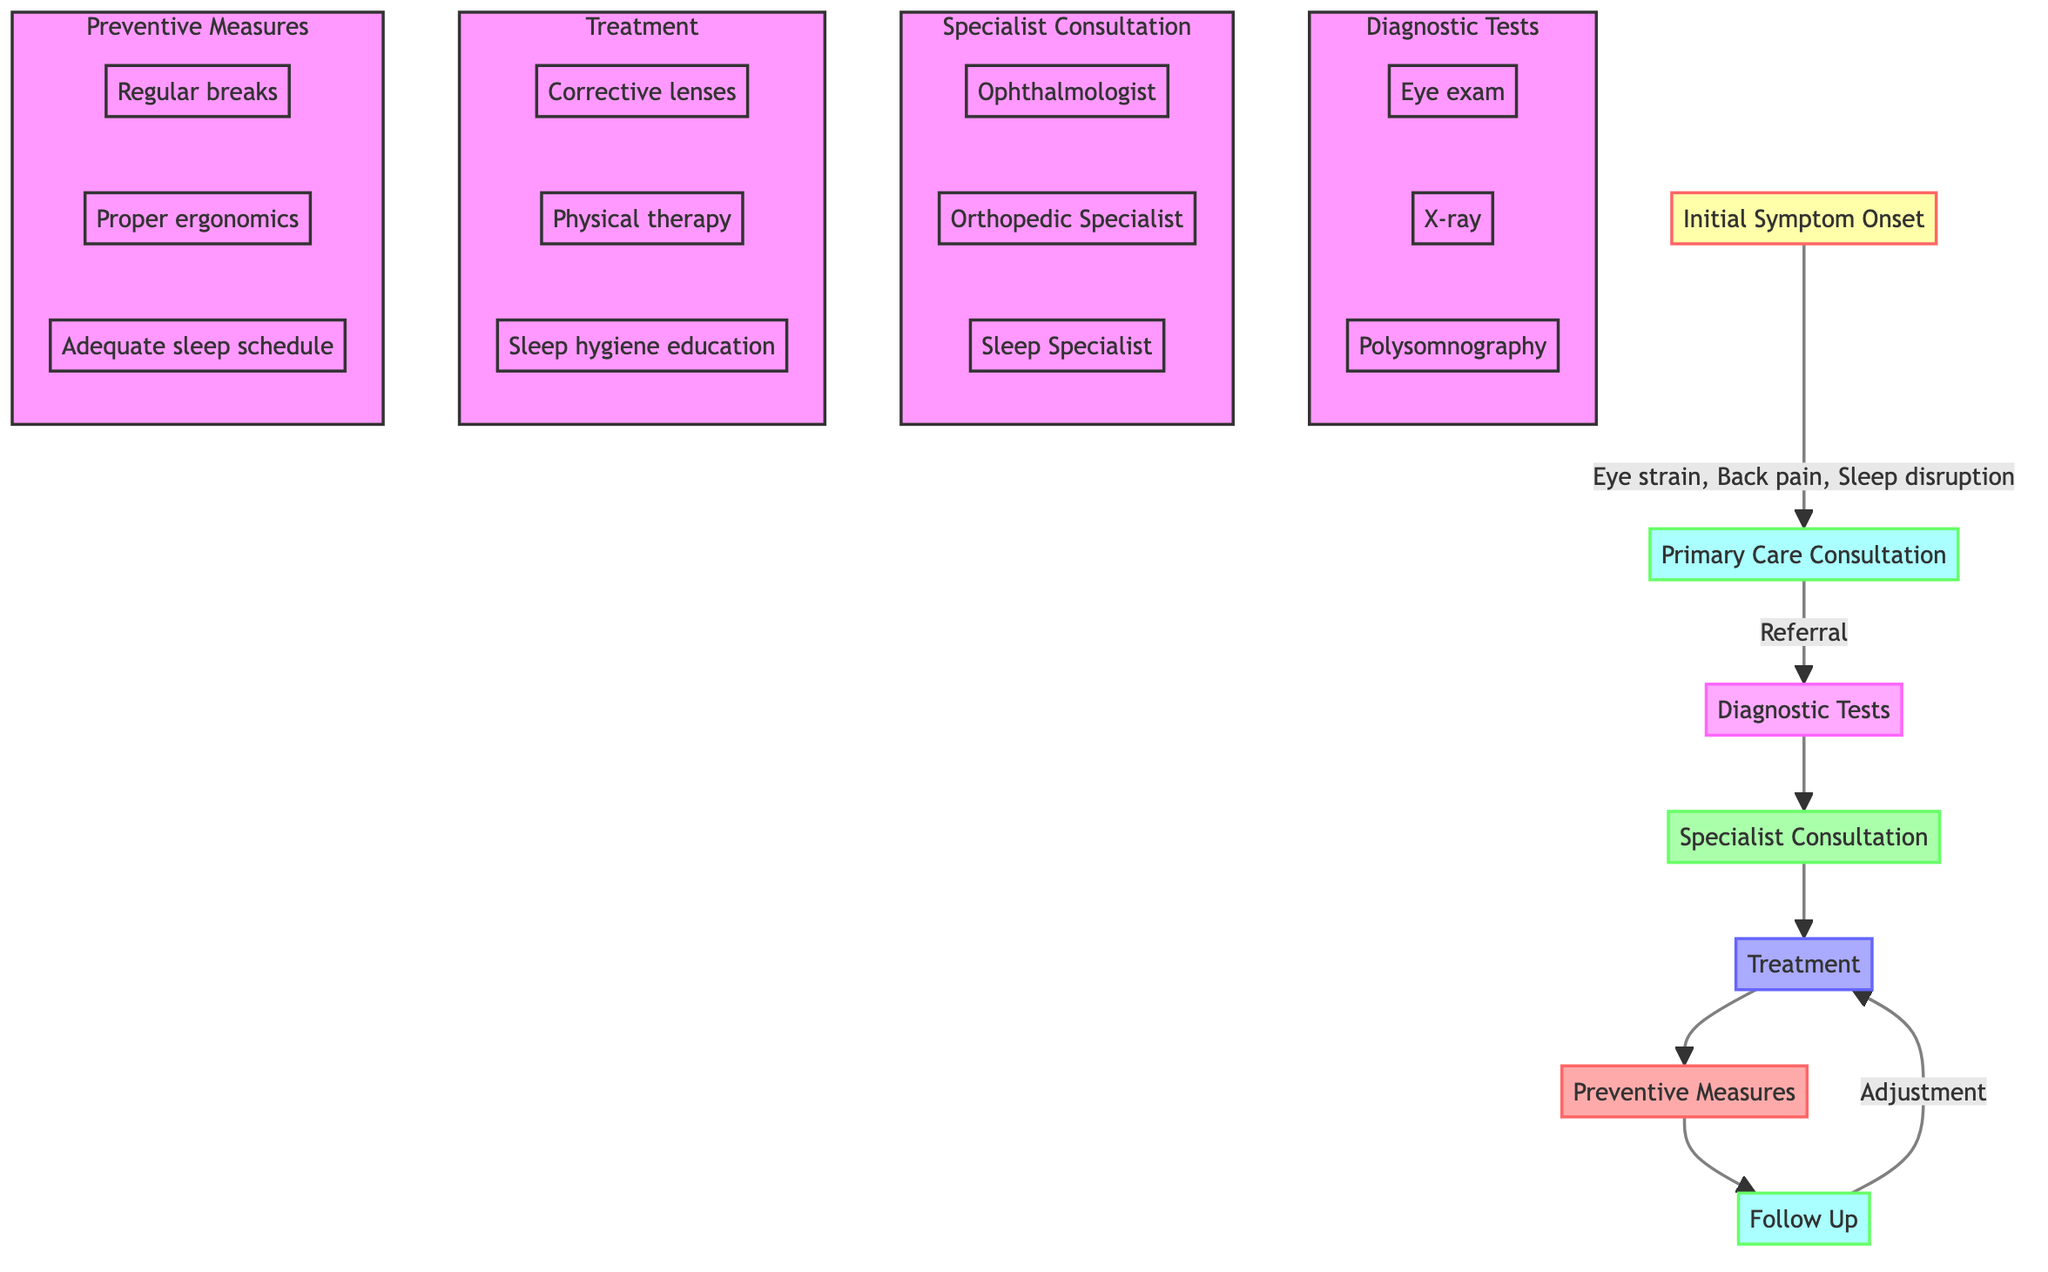What are common symptoms noted in the initial symptom onset? The diagram highlights "Eye strain," "Back pain," "Sleep disruption," and "Exposure to cold temperatures" as common symptoms during the initial symptom onset.
Answer: Eye strain, Back pain, Sleep disruption, Exposure to cold temperatures Who is the primary healthcare provider consulted for initial assessment? According to the diagram, the primary healthcare provider for the initial consultation is a "General Practitioner."
Answer: General Practitioner How many potential referrals are mentioned after primary care consultation? The diagram lists three potential referrals to specialists: "Ophthalmologist," "Orthopedic Specialist," and "Sleep Specialist," making a total of three potential referrals.
Answer: 3 What are the treatments provided by the sleep specialist? The diagram outlines three treatments for issues diagnosed by the sleep specialist: "Sleep hygiene education," "Cognitive Behavioral Therapy for Insomnia," and "Melatonin supplements."
Answer: Sleep hygiene education, Cognitive Behavioral Therapy for Insomnia, Melatonin supplements What type of ergonomic measures are recommended under preventive measures? The diagram indicates that "Proper ergonomics" and "Use of adjustable chairs and desks" are part of the preventive measures to address occupational health issues.
Answer: Proper ergonomics, Use of adjustable chairs and desks What diagnostic tests are performed by the orthopedic specialist? The diagram specifies that the orthopedic specialist performs diagnostic tests including "X-ray," "MRI scan," and "Physical assessment" to evaluate health issues.
Answer: X-ray, MRI scan, Physical assessment How is treatment adjusted according to the follow-up? The diagram states that treatment is adjusted "Based on follow-up assessments," indicating a responsive approach to the patient's progress and needs.
Answer: Based on follow-up assessments What measures are typically advised to prevent occupational health issues? The diagram includes preventive measures such as "Regular breaks," "Proper ergonomics," and "Adequate sleep schedule," which are typically advised to avoid these health issues.
Answer: Regular breaks, Proper ergonomics, Adequate sleep schedule 